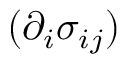<formula> <loc_0><loc_0><loc_500><loc_500>( \partial _ { i } \sigma _ { i j } )</formula> 